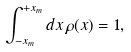<formula> <loc_0><loc_0><loc_500><loc_500>\int _ { - x _ { m } } ^ { + x _ { m } } d x \, \rho ( x ) = 1 ,</formula> 